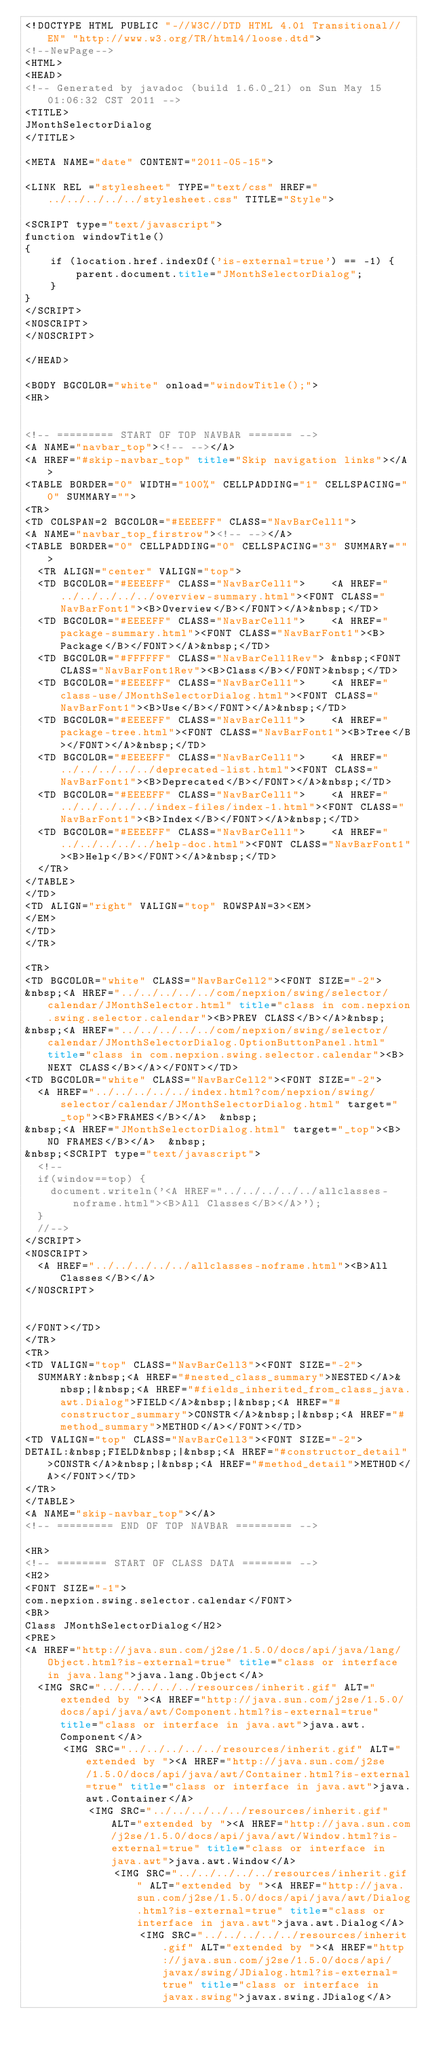<code> <loc_0><loc_0><loc_500><loc_500><_HTML_><!DOCTYPE HTML PUBLIC "-//W3C//DTD HTML 4.01 Transitional//EN" "http://www.w3.org/TR/html4/loose.dtd">
<!--NewPage-->
<HTML>
<HEAD>
<!-- Generated by javadoc (build 1.6.0_21) on Sun May 15 01:06:32 CST 2011 -->
<TITLE>
JMonthSelectorDialog
</TITLE>

<META NAME="date" CONTENT="2011-05-15">

<LINK REL ="stylesheet" TYPE="text/css" HREF="../../../../../stylesheet.css" TITLE="Style">

<SCRIPT type="text/javascript">
function windowTitle()
{
    if (location.href.indexOf('is-external=true') == -1) {
        parent.document.title="JMonthSelectorDialog";
    }
}
</SCRIPT>
<NOSCRIPT>
</NOSCRIPT>

</HEAD>

<BODY BGCOLOR="white" onload="windowTitle();">
<HR>


<!-- ========= START OF TOP NAVBAR ======= -->
<A NAME="navbar_top"><!-- --></A>
<A HREF="#skip-navbar_top" title="Skip navigation links"></A>
<TABLE BORDER="0" WIDTH="100%" CELLPADDING="1" CELLSPACING="0" SUMMARY="">
<TR>
<TD COLSPAN=2 BGCOLOR="#EEEEFF" CLASS="NavBarCell1">
<A NAME="navbar_top_firstrow"><!-- --></A>
<TABLE BORDER="0" CELLPADDING="0" CELLSPACING="3" SUMMARY="">
  <TR ALIGN="center" VALIGN="top">
  <TD BGCOLOR="#EEEEFF" CLASS="NavBarCell1">    <A HREF="../../../../../overview-summary.html"><FONT CLASS="NavBarFont1"><B>Overview</B></FONT></A>&nbsp;</TD>
  <TD BGCOLOR="#EEEEFF" CLASS="NavBarCell1">    <A HREF="package-summary.html"><FONT CLASS="NavBarFont1"><B>Package</B></FONT></A>&nbsp;</TD>
  <TD BGCOLOR="#FFFFFF" CLASS="NavBarCell1Rev"> &nbsp;<FONT CLASS="NavBarFont1Rev"><B>Class</B></FONT>&nbsp;</TD>
  <TD BGCOLOR="#EEEEFF" CLASS="NavBarCell1">    <A HREF="class-use/JMonthSelectorDialog.html"><FONT CLASS="NavBarFont1"><B>Use</B></FONT></A>&nbsp;</TD>
  <TD BGCOLOR="#EEEEFF" CLASS="NavBarCell1">    <A HREF="package-tree.html"><FONT CLASS="NavBarFont1"><B>Tree</B></FONT></A>&nbsp;</TD>
  <TD BGCOLOR="#EEEEFF" CLASS="NavBarCell1">    <A HREF="../../../../../deprecated-list.html"><FONT CLASS="NavBarFont1"><B>Deprecated</B></FONT></A>&nbsp;</TD>
  <TD BGCOLOR="#EEEEFF" CLASS="NavBarCell1">    <A HREF="../../../../../index-files/index-1.html"><FONT CLASS="NavBarFont1"><B>Index</B></FONT></A>&nbsp;</TD>
  <TD BGCOLOR="#EEEEFF" CLASS="NavBarCell1">    <A HREF="../../../../../help-doc.html"><FONT CLASS="NavBarFont1"><B>Help</B></FONT></A>&nbsp;</TD>
  </TR>
</TABLE>
</TD>
<TD ALIGN="right" VALIGN="top" ROWSPAN=3><EM>
</EM>
</TD>
</TR>

<TR>
<TD BGCOLOR="white" CLASS="NavBarCell2"><FONT SIZE="-2">
&nbsp;<A HREF="../../../../../com/nepxion/swing/selector/calendar/JMonthSelector.html" title="class in com.nepxion.swing.selector.calendar"><B>PREV CLASS</B></A>&nbsp;
&nbsp;<A HREF="../../../../../com/nepxion/swing/selector/calendar/JMonthSelectorDialog.OptionButtonPanel.html" title="class in com.nepxion.swing.selector.calendar"><B>NEXT CLASS</B></A></FONT></TD>
<TD BGCOLOR="white" CLASS="NavBarCell2"><FONT SIZE="-2">
  <A HREF="../../../../../index.html?com/nepxion/swing/selector/calendar/JMonthSelectorDialog.html" target="_top"><B>FRAMES</B></A>  &nbsp;
&nbsp;<A HREF="JMonthSelectorDialog.html" target="_top"><B>NO FRAMES</B></A>  &nbsp;
&nbsp;<SCRIPT type="text/javascript">
  <!--
  if(window==top) {
    document.writeln('<A HREF="../../../../../allclasses-noframe.html"><B>All Classes</B></A>');
  }
  //-->
</SCRIPT>
<NOSCRIPT>
  <A HREF="../../../../../allclasses-noframe.html"><B>All Classes</B></A>
</NOSCRIPT>


</FONT></TD>
</TR>
<TR>
<TD VALIGN="top" CLASS="NavBarCell3"><FONT SIZE="-2">
  SUMMARY:&nbsp;<A HREF="#nested_class_summary">NESTED</A>&nbsp;|&nbsp;<A HREF="#fields_inherited_from_class_java.awt.Dialog">FIELD</A>&nbsp;|&nbsp;<A HREF="#constructor_summary">CONSTR</A>&nbsp;|&nbsp;<A HREF="#method_summary">METHOD</A></FONT></TD>
<TD VALIGN="top" CLASS="NavBarCell3"><FONT SIZE="-2">
DETAIL:&nbsp;FIELD&nbsp;|&nbsp;<A HREF="#constructor_detail">CONSTR</A>&nbsp;|&nbsp;<A HREF="#method_detail">METHOD</A></FONT></TD>
</TR>
</TABLE>
<A NAME="skip-navbar_top"></A>
<!-- ========= END OF TOP NAVBAR ========= -->

<HR>
<!-- ======== START OF CLASS DATA ======== -->
<H2>
<FONT SIZE="-1">
com.nepxion.swing.selector.calendar</FONT>
<BR>
Class JMonthSelectorDialog</H2>
<PRE>
<A HREF="http://java.sun.com/j2se/1.5.0/docs/api/java/lang/Object.html?is-external=true" title="class or interface in java.lang">java.lang.Object</A>
  <IMG SRC="../../../../../resources/inherit.gif" ALT="extended by "><A HREF="http://java.sun.com/j2se/1.5.0/docs/api/java/awt/Component.html?is-external=true" title="class or interface in java.awt">java.awt.Component</A>
      <IMG SRC="../../../../../resources/inherit.gif" ALT="extended by "><A HREF="http://java.sun.com/j2se/1.5.0/docs/api/java/awt/Container.html?is-external=true" title="class or interface in java.awt">java.awt.Container</A>
          <IMG SRC="../../../../../resources/inherit.gif" ALT="extended by "><A HREF="http://java.sun.com/j2se/1.5.0/docs/api/java/awt/Window.html?is-external=true" title="class or interface in java.awt">java.awt.Window</A>
              <IMG SRC="../../../../../resources/inherit.gif" ALT="extended by "><A HREF="http://java.sun.com/j2se/1.5.0/docs/api/java/awt/Dialog.html?is-external=true" title="class or interface in java.awt">java.awt.Dialog</A>
                  <IMG SRC="../../../../../resources/inherit.gif" ALT="extended by "><A HREF="http://java.sun.com/j2se/1.5.0/docs/api/javax/swing/JDialog.html?is-external=true" title="class or interface in javax.swing">javax.swing.JDialog</A></code> 